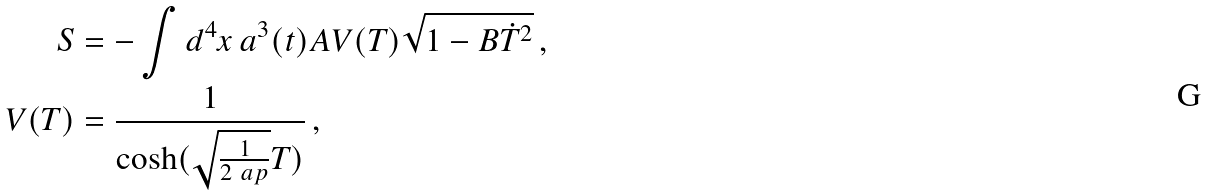<formula> <loc_0><loc_0><loc_500><loc_500>S & = - \int d ^ { 4 } x \, a ^ { 3 } ( t ) A V ( T ) \sqrt { 1 - B \dot { T } ^ { 2 } } \, , \\ V ( T ) & = \frac { 1 } { \cosh ( \sqrt { \frac { 1 } { 2 \ a p } } T ) } \, ,</formula> 